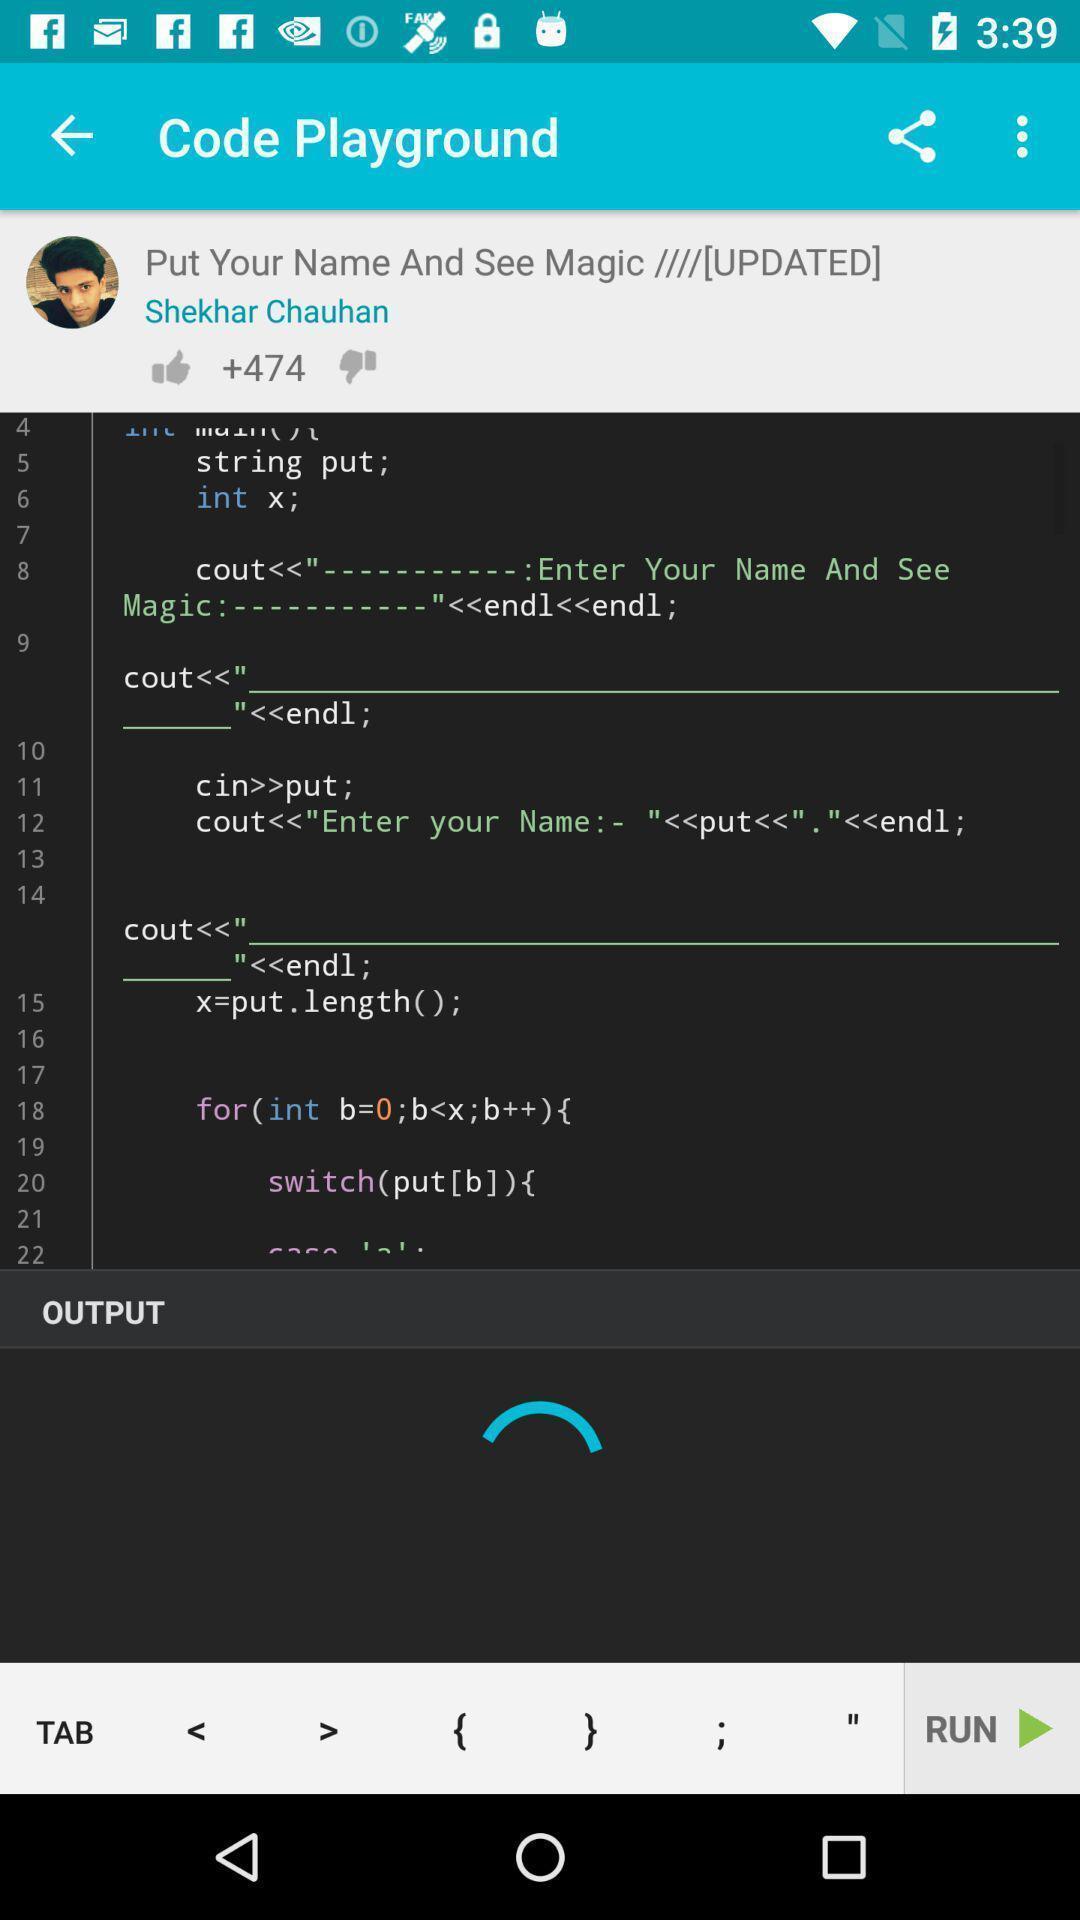Give me a summary of this screen capture. Screen page of a learning application. 